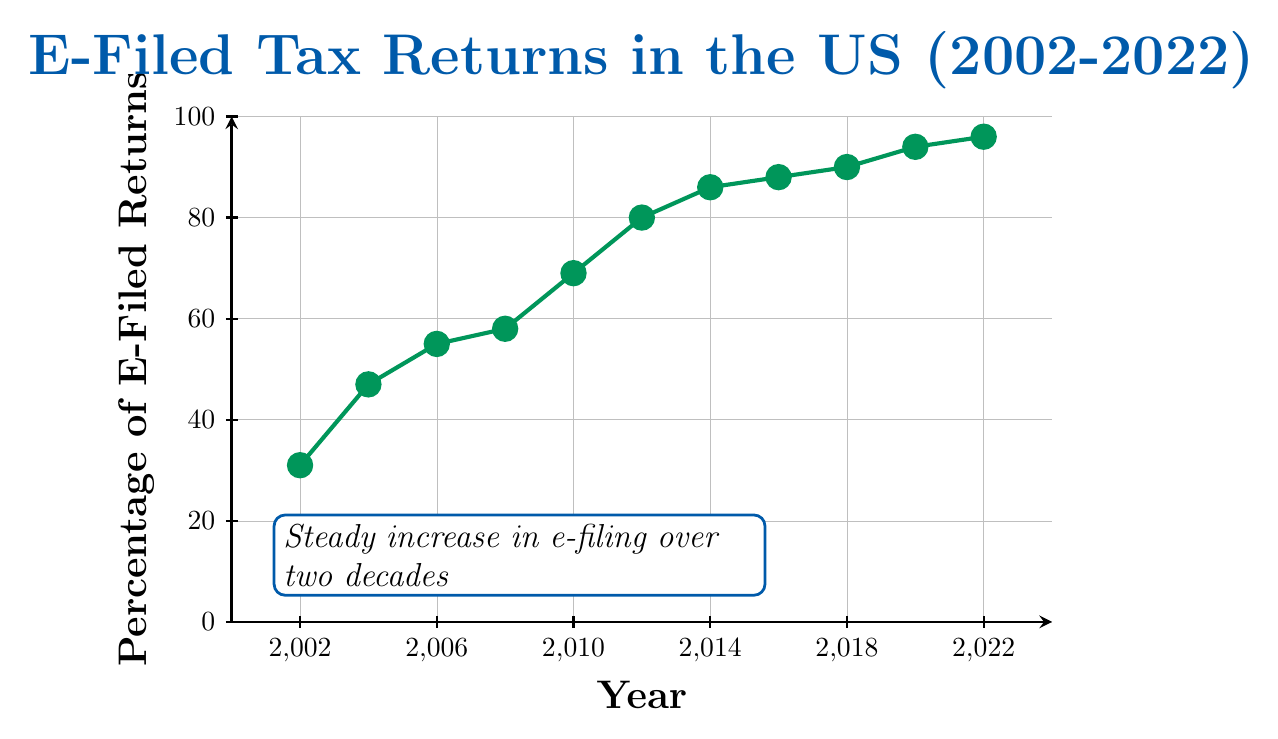What is the percentage of e-filed tax returns in 2010? According to the figure, locate the point corresponding to the year 2010 on the x-axis. The y-value at this point represents the percentage of e-filed returns, which is 69%.
Answer: 69% In which year did the percentage of e-filed tax returns first exceed 80%? On the x-axis, find the year where the y-value first goes beyond 80%. This happens between 2012 and 2014. According to the figure, in 2012, the percentage is 80%, so it is in 2014 that it first exceeds 80%.
Answer: 2014 What is the average percentage of e-filed tax returns from 2002 to 2022? To find the average, add the percentages for all the given years and divide by the number of years. 
(31 + 47 + 55 + 58 + 69 + 80 + 86 + 88 + 90 + 94 + 96) / 11 = 794 / 11 = 72.18.
Answer: 72.18% How much did the percentage of e-filed tax returns increase from 2002 to 2022? Subtract the percentage in 2002 from the percentage in 2022. 
96% (2022) - 31% (2002) = 65%.
Answer: 65% Between which years did the percentage of e-filed tax returns show the largest increase? Calculate the differences between consecutive years and identify the largest one. 
(47-31=16), (55-47=8), (58-55=3), (69-58=11), (80-69=11), (86-80=6), (88-86=2), (90-88=2), (94-90=4), (96-94=2). The largest increase is between 2004 and 2010, both 16% and 11% increments from 2002 to 2006 and 2006 to 2010 respectively. The highest among these is a rise of 16 between 2002 and 2004.
Answer: 2002 and 2004 Which year shows the smallest increase from its previous data point? Calculate the smallest differences between consecutive years.
(47-31=16), (55-47=8), (58-55=3), (69-58=11), (80-69=11), (86-80=6), (88-86=2), (90-88=2), (94-90=4), (96-94=2). The smallest increase is between 86 and 88, (2) i.e., from 2014 to 2016.
Answer: 2014 to 2016 What is the median percentage of e-filed tax returns over the years presented? To find the median, sort the percentages and find the middle value.
31, 47, 55, 58, 69, 80, 86, 88, 90, 94, 96. The median value is the 6th number in this sorted list, which is 80.
Answer: 80 How does the percentage of e-filed returns in 2020 compare to that in 2018? Compare the y-values for the years 2020 and 2018 by looking at the figure.
The percentage was 90% in 2018 and 94% in 2020, indicating that the percentage in 2020 is greater than in 2018.
Answer: Greater What can be observed about the trend in e-filed tax returns over the two decades presented? Observe the overall shape and direction of the line in the figure. The percentage of e-filed returns shows a steady increase from 2002 to 2022, indicating a positive growth trend.
Answer: Steady increase Which years demonstrated a percentage increase from less than half to more than half? Identify the years where the percentage moved from below 50% to above 50%.
In 2004, it was 47%, and in 2006, it was 55%, indicating that this transition from less than half to more than half happened between 2004 and 2006.
Answer: 2004 to 2006 